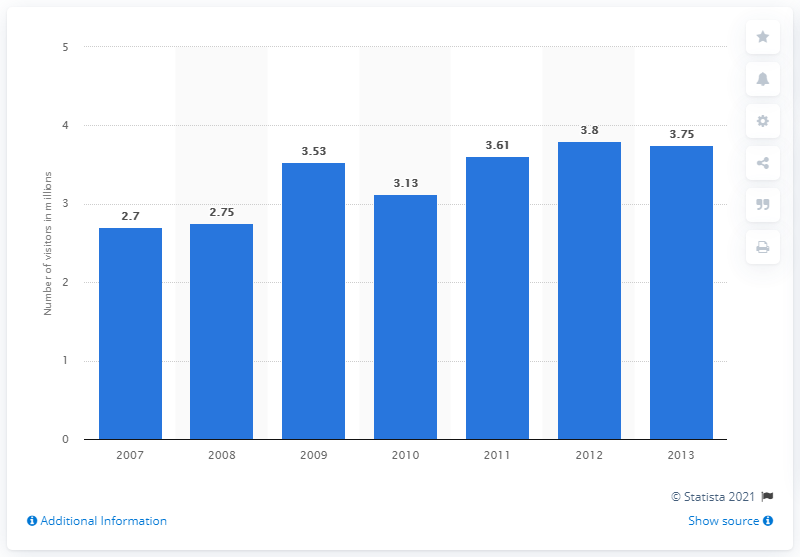Point out several critical features in this image. In 2013, the Centre Pompidou in Paris was visited by 3.75 million visitors. 